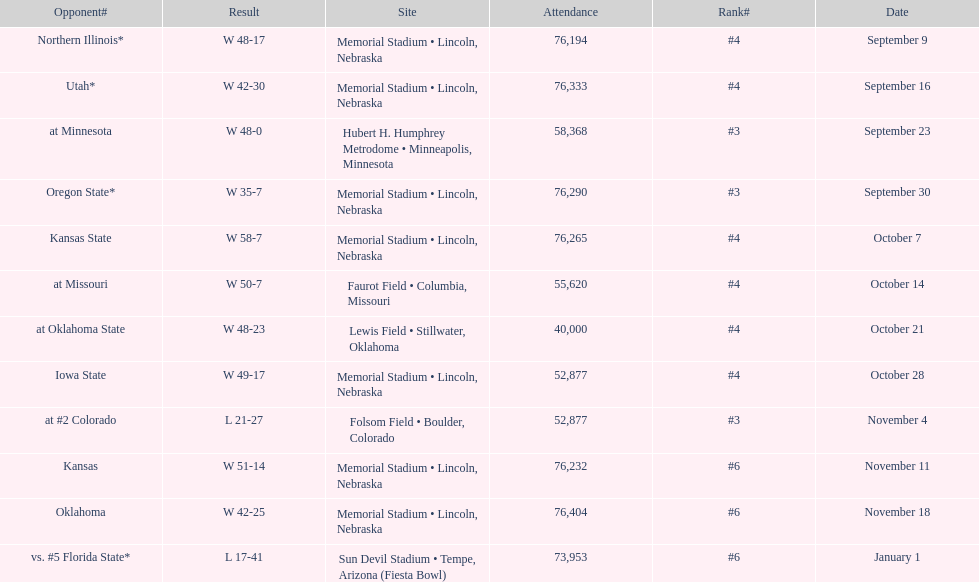When is the first game? September 9. Would you mind parsing the complete table? {'header': ['Opponent#', 'Result', 'Site', 'Attendance', 'Rank#', 'Date'], 'rows': [['Northern Illinois*', 'W\xa048-17', 'Memorial Stadium • Lincoln, Nebraska', '76,194', '#4', 'September 9'], ['Utah*', 'W\xa042-30', 'Memorial Stadium • Lincoln, Nebraska', '76,333', '#4', 'September 16'], ['at\xa0Minnesota', 'W\xa048-0', 'Hubert H. Humphrey Metrodome • Minneapolis, Minnesota', '58,368', '#3', 'September 23'], ['Oregon State*', 'W\xa035-7', 'Memorial Stadium • Lincoln, Nebraska', '76,290', '#3', 'September 30'], ['Kansas State', 'W\xa058-7', 'Memorial Stadium • Lincoln, Nebraska', '76,265', '#4', 'October 7'], ['at\xa0Missouri', 'W\xa050-7', 'Faurot Field • Columbia, Missouri', '55,620', '#4', 'October 14'], ['at\xa0Oklahoma State', 'W\xa048-23', 'Lewis Field • Stillwater, Oklahoma', '40,000', '#4', 'October 21'], ['Iowa State', 'W\xa049-17', 'Memorial Stadium • Lincoln, Nebraska', '52,877', '#4', 'October 28'], ['at\xa0#2\xa0Colorado', 'L\xa021-27', 'Folsom Field • Boulder, Colorado', '52,877', '#3', 'November 4'], ['Kansas', 'W\xa051-14', 'Memorial Stadium • Lincoln, Nebraska', '76,232', '#6', 'November 11'], ['Oklahoma', 'W\xa042-25', 'Memorial Stadium • Lincoln, Nebraska', '76,404', '#6', 'November 18'], ['vs.\xa0#5\xa0Florida State*', 'L\xa017-41', 'Sun Devil Stadium • Tempe, Arizona (Fiesta Bowl)', '73,953', '#6', 'January 1']]} 